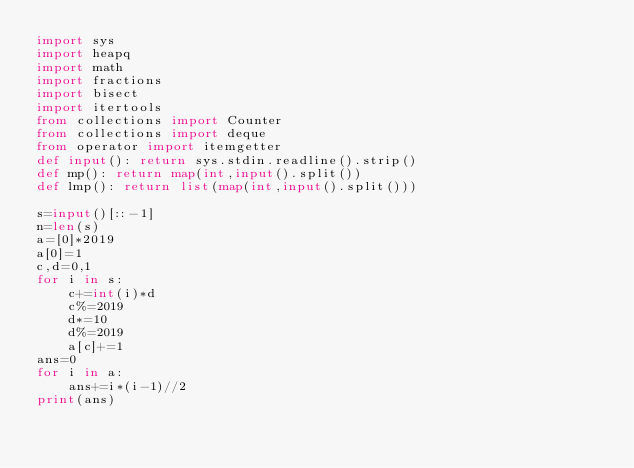Convert code to text. <code><loc_0><loc_0><loc_500><loc_500><_Python_>import sys
import heapq
import math
import fractions
import bisect
import itertools
from collections import Counter
from collections import deque
from operator import itemgetter
def input(): return sys.stdin.readline().strip()
def mp(): return map(int,input().split())
def lmp(): return list(map(int,input().split()))

s=input()[::-1]
n=len(s)
a=[0]*2019
a[0]=1
c,d=0,1
for i in s:
    c+=int(i)*d
    c%=2019
    d*=10
    d%=2019
    a[c]+=1
ans=0
for i in a:
    ans+=i*(i-1)//2
print(ans)</code> 